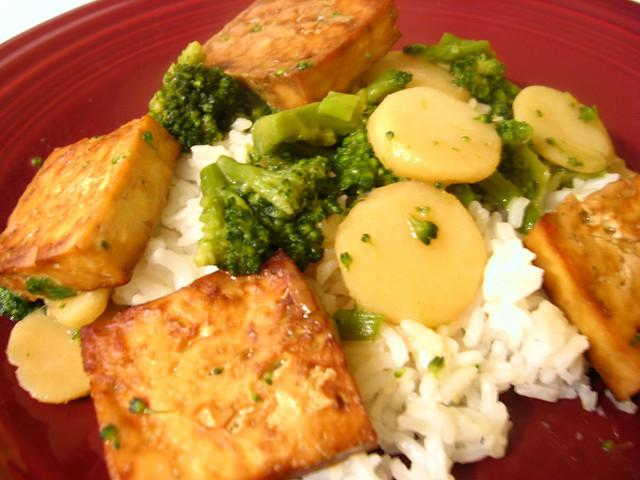Which item on the plate is highest in carbs? Please explain your reasoning. rice. The item is rice. 